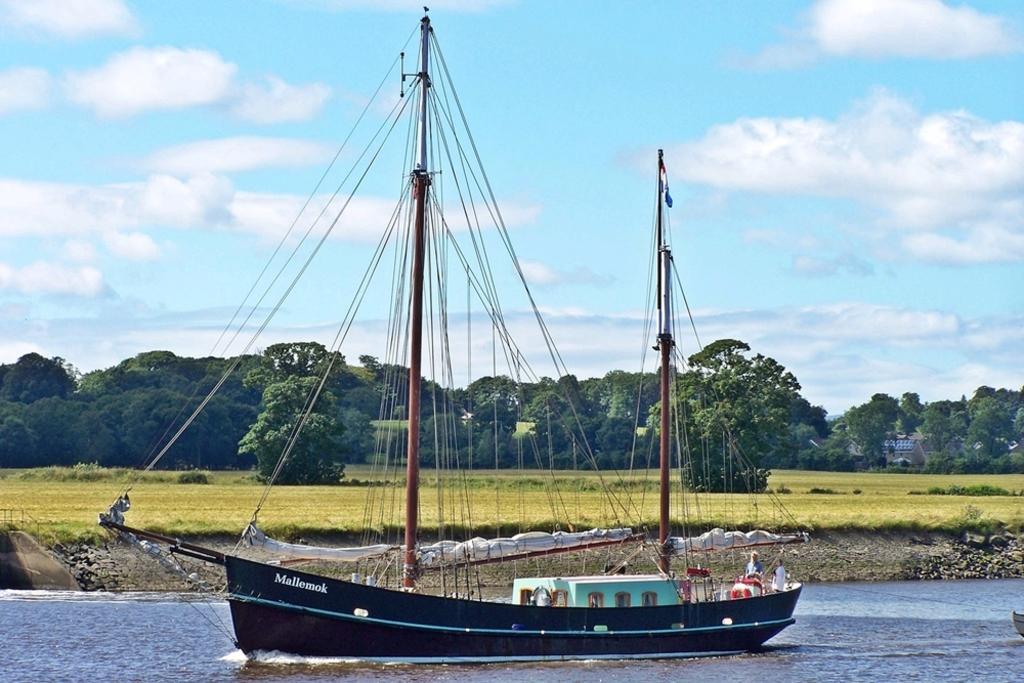Describe this image in one or two sentences. There is a boat on the water. In the background, there are trees and grass on the ground and there are clouds in the blue sky. 